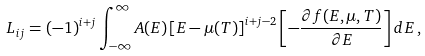<formula> <loc_0><loc_0><loc_500><loc_500>L _ { i j } = ( - 1 ) ^ { i + j } \int _ { - \infty } ^ { \infty } A ( E ) \left [ E - \mu ( T ) \right ] ^ { i + j - 2 } \left [ - \frac { \partial f ( E , \mu , T ) } { \partial E } \right ] d E \, ,</formula> 